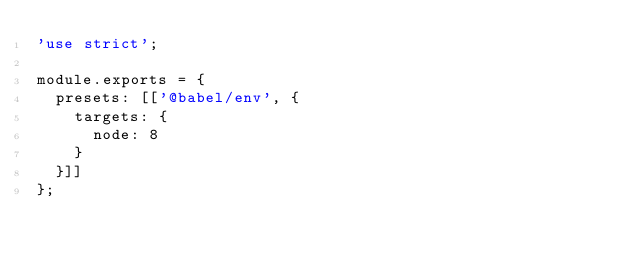Convert code to text. <code><loc_0><loc_0><loc_500><loc_500><_JavaScript_>'use strict';

module.exports = {
	presets: [['@babel/env', {
		targets: {
			node: 8
		}
	}]]
};
</code> 